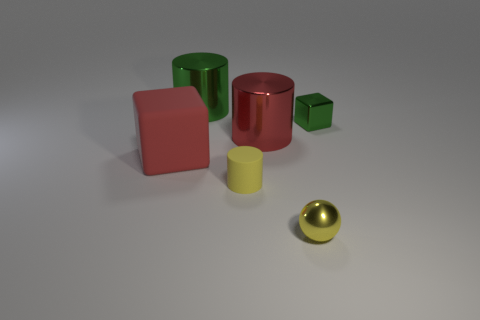Is there a matte block that has the same size as the green cylinder?
Keep it short and to the point. Yes. Does the shiny cylinder that is behind the red metal cylinder have the same color as the block right of the big red metal cylinder?
Your answer should be compact. Yes. Is there a shiny cylinder of the same color as the tiny block?
Provide a short and direct response. Yes. How many other objects are the same shape as the big red shiny thing?
Give a very brief answer. 2. The small object behind the red cylinder has what shape?
Offer a terse response. Cube. Does the small yellow rubber object have the same shape as the red thing in front of the red cylinder?
Offer a very short reply. No. There is a object that is on the left side of the red metallic cylinder and in front of the big red rubber thing; what is its size?
Ensure brevity in your answer.  Small. What color is the cylinder that is both in front of the tiny green shiny object and behind the rubber cylinder?
Your answer should be very brief. Red. Is the number of small metal objects that are behind the red metal cylinder less than the number of matte blocks that are left of the red matte thing?
Offer a very short reply. No. There is a large green shiny thing; what shape is it?
Your answer should be compact. Cylinder. 